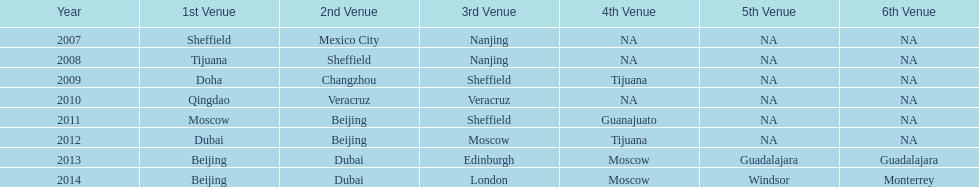Did 2007 or 2012 have a higher count of venues? 2012. 